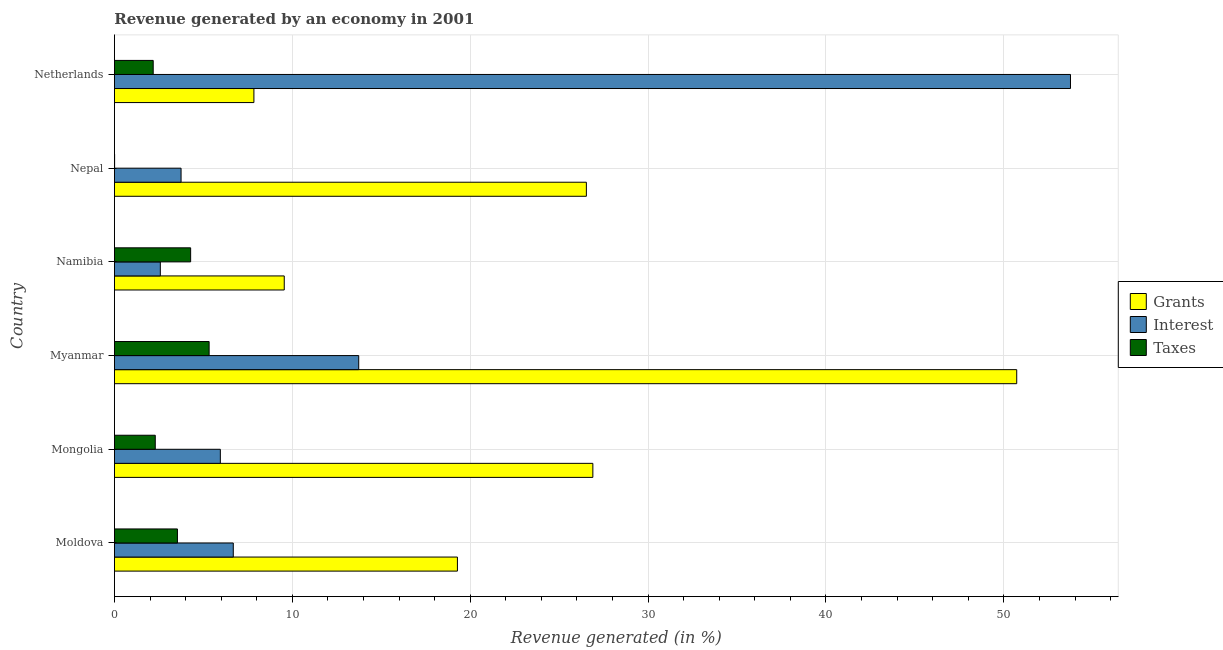How many groups of bars are there?
Your response must be concise. 6. Are the number of bars on each tick of the Y-axis equal?
Your answer should be compact. Yes. How many bars are there on the 6th tick from the top?
Make the answer very short. 3. What is the label of the 4th group of bars from the top?
Offer a terse response. Myanmar. What is the percentage of revenue generated by grants in Netherlands?
Ensure brevity in your answer.  7.84. Across all countries, what is the maximum percentage of revenue generated by interest?
Offer a terse response. 53.74. Across all countries, what is the minimum percentage of revenue generated by interest?
Provide a short and direct response. 2.58. In which country was the percentage of revenue generated by grants maximum?
Keep it short and to the point. Myanmar. What is the total percentage of revenue generated by taxes in the graph?
Your response must be concise. 17.64. What is the difference between the percentage of revenue generated by grants in Moldova and that in Namibia?
Give a very brief answer. 9.73. What is the difference between the percentage of revenue generated by taxes in Netherlands and the percentage of revenue generated by interest in Moldova?
Provide a succinct answer. -4.5. What is the average percentage of revenue generated by taxes per country?
Your answer should be compact. 2.94. What is the difference between the percentage of revenue generated by grants and percentage of revenue generated by taxes in Moldova?
Your answer should be very brief. 15.74. What is the ratio of the percentage of revenue generated by grants in Mongolia to that in Nepal?
Your answer should be very brief. 1.01. Is the percentage of revenue generated by taxes in Mongolia less than that in Namibia?
Make the answer very short. Yes. Is the difference between the percentage of revenue generated by grants in Moldova and Myanmar greater than the difference between the percentage of revenue generated by taxes in Moldova and Myanmar?
Give a very brief answer. No. What is the difference between the highest and the second highest percentage of revenue generated by grants?
Offer a terse response. 23.83. What is the difference between the highest and the lowest percentage of revenue generated by taxes?
Ensure brevity in your answer.  5.31. What does the 2nd bar from the top in Netherlands represents?
Make the answer very short. Interest. What does the 3rd bar from the bottom in Netherlands represents?
Provide a succinct answer. Taxes. Is it the case that in every country, the sum of the percentage of revenue generated by grants and percentage of revenue generated by interest is greater than the percentage of revenue generated by taxes?
Ensure brevity in your answer.  Yes. How many countries are there in the graph?
Keep it short and to the point. 6. Are the values on the major ticks of X-axis written in scientific E-notation?
Provide a succinct answer. No. Does the graph contain any zero values?
Provide a short and direct response. No. Where does the legend appear in the graph?
Provide a succinct answer. Center right. How many legend labels are there?
Ensure brevity in your answer.  3. What is the title of the graph?
Your answer should be very brief. Revenue generated by an economy in 2001. Does "Taxes" appear as one of the legend labels in the graph?
Keep it short and to the point. Yes. What is the label or title of the X-axis?
Your answer should be very brief. Revenue generated (in %). What is the label or title of the Y-axis?
Your answer should be compact. Country. What is the Revenue generated (in %) of Grants in Moldova?
Offer a very short reply. 19.28. What is the Revenue generated (in %) of Interest in Moldova?
Make the answer very short. 6.68. What is the Revenue generated (in %) in Taxes in Moldova?
Provide a short and direct response. 3.54. What is the Revenue generated (in %) of Grants in Mongolia?
Make the answer very short. 26.89. What is the Revenue generated (in %) of Interest in Mongolia?
Make the answer very short. 5.95. What is the Revenue generated (in %) of Taxes in Mongolia?
Give a very brief answer. 2.3. What is the Revenue generated (in %) of Grants in Myanmar?
Provide a short and direct response. 50.72. What is the Revenue generated (in %) in Interest in Myanmar?
Keep it short and to the point. 13.73. What is the Revenue generated (in %) of Taxes in Myanmar?
Provide a short and direct response. 5.32. What is the Revenue generated (in %) of Grants in Namibia?
Give a very brief answer. 9.55. What is the Revenue generated (in %) in Interest in Namibia?
Keep it short and to the point. 2.58. What is the Revenue generated (in %) of Taxes in Namibia?
Offer a terse response. 4.28. What is the Revenue generated (in %) in Grants in Nepal?
Offer a very short reply. 26.53. What is the Revenue generated (in %) in Interest in Nepal?
Provide a succinct answer. 3.75. What is the Revenue generated (in %) of Taxes in Nepal?
Your answer should be very brief. 0.01. What is the Revenue generated (in %) in Grants in Netherlands?
Provide a short and direct response. 7.84. What is the Revenue generated (in %) of Interest in Netherlands?
Keep it short and to the point. 53.74. What is the Revenue generated (in %) of Taxes in Netherlands?
Provide a short and direct response. 2.18. Across all countries, what is the maximum Revenue generated (in %) of Grants?
Keep it short and to the point. 50.72. Across all countries, what is the maximum Revenue generated (in %) of Interest?
Offer a very short reply. 53.74. Across all countries, what is the maximum Revenue generated (in %) in Taxes?
Your answer should be very brief. 5.32. Across all countries, what is the minimum Revenue generated (in %) in Grants?
Your answer should be very brief. 7.84. Across all countries, what is the minimum Revenue generated (in %) in Interest?
Your answer should be compact. 2.58. Across all countries, what is the minimum Revenue generated (in %) of Taxes?
Your response must be concise. 0.01. What is the total Revenue generated (in %) of Grants in the graph?
Offer a terse response. 140.81. What is the total Revenue generated (in %) in Interest in the graph?
Your answer should be compact. 86.44. What is the total Revenue generated (in %) in Taxes in the graph?
Make the answer very short. 17.64. What is the difference between the Revenue generated (in %) in Grants in Moldova and that in Mongolia?
Offer a terse response. -7.61. What is the difference between the Revenue generated (in %) of Interest in Moldova and that in Mongolia?
Provide a succinct answer. 0.73. What is the difference between the Revenue generated (in %) in Taxes in Moldova and that in Mongolia?
Your answer should be very brief. 1.25. What is the difference between the Revenue generated (in %) of Grants in Moldova and that in Myanmar?
Provide a short and direct response. -31.44. What is the difference between the Revenue generated (in %) of Interest in Moldova and that in Myanmar?
Offer a terse response. -7.05. What is the difference between the Revenue generated (in %) of Taxes in Moldova and that in Myanmar?
Your answer should be compact. -1.78. What is the difference between the Revenue generated (in %) of Grants in Moldova and that in Namibia?
Give a very brief answer. 9.73. What is the difference between the Revenue generated (in %) in Interest in Moldova and that in Namibia?
Ensure brevity in your answer.  4.1. What is the difference between the Revenue generated (in %) of Taxes in Moldova and that in Namibia?
Provide a succinct answer. -0.74. What is the difference between the Revenue generated (in %) in Grants in Moldova and that in Nepal?
Provide a short and direct response. -7.25. What is the difference between the Revenue generated (in %) in Interest in Moldova and that in Nepal?
Ensure brevity in your answer.  2.94. What is the difference between the Revenue generated (in %) in Taxes in Moldova and that in Nepal?
Ensure brevity in your answer.  3.53. What is the difference between the Revenue generated (in %) of Grants in Moldova and that in Netherlands?
Make the answer very short. 11.44. What is the difference between the Revenue generated (in %) in Interest in Moldova and that in Netherlands?
Give a very brief answer. -47.06. What is the difference between the Revenue generated (in %) of Taxes in Moldova and that in Netherlands?
Ensure brevity in your answer.  1.36. What is the difference between the Revenue generated (in %) in Grants in Mongolia and that in Myanmar?
Your response must be concise. -23.83. What is the difference between the Revenue generated (in %) in Interest in Mongolia and that in Myanmar?
Make the answer very short. -7.78. What is the difference between the Revenue generated (in %) of Taxes in Mongolia and that in Myanmar?
Your answer should be compact. -3.03. What is the difference between the Revenue generated (in %) in Grants in Mongolia and that in Namibia?
Keep it short and to the point. 17.35. What is the difference between the Revenue generated (in %) of Interest in Mongolia and that in Namibia?
Your answer should be very brief. 3.37. What is the difference between the Revenue generated (in %) in Taxes in Mongolia and that in Namibia?
Offer a terse response. -1.99. What is the difference between the Revenue generated (in %) in Grants in Mongolia and that in Nepal?
Provide a short and direct response. 0.37. What is the difference between the Revenue generated (in %) in Interest in Mongolia and that in Nepal?
Your response must be concise. 2.21. What is the difference between the Revenue generated (in %) in Taxes in Mongolia and that in Nepal?
Your response must be concise. 2.29. What is the difference between the Revenue generated (in %) in Grants in Mongolia and that in Netherlands?
Ensure brevity in your answer.  19.05. What is the difference between the Revenue generated (in %) in Interest in Mongolia and that in Netherlands?
Make the answer very short. -47.79. What is the difference between the Revenue generated (in %) of Taxes in Mongolia and that in Netherlands?
Provide a succinct answer. 0.12. What is the difference between the Revenue generated (in %) in Grants in Myanmar and that in Namibia?
Provide a succinct answer. 41.18. What is the difference between the Revenue generated (in %) in Interest in Myanmar and that in Namibia?
Your response must be concise. 11.15. What is the difference between the Revenue generated (in %) of Taxes in Myanmar and that in Namibia?
Offer a terse response. 1.04. What is the difference between the Revenue generated (in %) of Grants in Myanmar and that in Nepal?
Your answer should be compact. 24.19. What is the difference between the Revenue generated (in %) of Interest in Myanmar and that in Nepal?
Offer a terse response. 9.99. What is the difference between the Revenue generated (in %) of Taxes in Myanmar and that in Nepal?
Give a very brief answer. 5.31. What is the difference between the Revenue generated (in %) in Grants in Myanmar and that in Netherlands?
Provide a succinct answer. 42.88. What is the difference between the Revenue generated (in %) in Interest in Myanmar and that in Netherlands?
Your response must be concise. -40.01. What is the difference between the Revenue generated (in %) of Taxes in Myanmar and that in Netherlands?
Your response must be concise. 3.14. What is the difference between the Revenue generated (in %) in Grants in Namibia and that in Nepal?
Your answer should be compact. -16.98. What is the difference between the Revenue generated (in %) of Interest in Namibia and that in Nepal?
Provide a succinct answer. -1.17. What is the difference between the Revenue generated (in %) of Taxes in Namibia and that in Nepal?
Your answer should be compact. 4.27. What is the difference between the Revenue generated (in %) in Grants in Namibia and that in Netherlands?
Your answer should be compact. 1.71. What is the difference between the Revenue generated (in %) in Interest in Namibia and that in Netherlands?
Give a very brief answer. -51.16. What is the difference between the Revenue generated (in %) of Taxes in Namibia and that in Netherlands?
Provide a succinct answer. 2.1. What is the difference between the Revenue generated (in %) of Grants in Nepal and that in Netherlands?
Give a very brief answer. 18.69. What is the difference between the Revenue generated (in %) of Interest in Nepal and that in Netherlands?
Offer a very short reply. -50. What is the difference between the Revenue generated (in %) in Taxes in Nepal and that in Netherlands?
Keep it short and to the point. -2.17. What is the difference between the Revenue generated (in %) of Grants in Moldova and the Revenue generated (in %) of Interest in Mongolia?
Offer a very short reply. 13.33. What is the difference between the Revenue generated (in %) of Grants in Moldova and the Revenue generated (in %) of Taxes in Mongolia?
Keep it short and to the point. 16.99. What is the difference between the Revenue generated (in %) of Interest in Moldova and the Revenue generated (in %) of Taxes in Mongolia?
Offer a very short reply. 4.39. What is the difference between the Revenue generated (in %) in Grants in Moldova and the Revenue generated (in %) in Interest in Myanmar?
Ensure brevity in your answer.  5.55. What is the difference between the Revenue generated (in %) in Grants in Moldova and the Revenue generated (in %) in Taxes in Myanmar?
Offer a very short reply. 13.96. What is the difference between the Revenue generated (in %) in Interest in Moldova and the Revenue generated (in %) in Taxes in Myanmar?
Your response must be concise. 1.36. What is the difference between the Revenue generated (in %) in Grants in Moldova and the Revenue generated (in %) in Interest in Namibia?
Keep it short and to the point. 16.7. What is the difference between the Revenue generated (in %) in Grants in Moldova and the Revenue generated (in %) in Taxes in Namibia?
Offer a very short reply. 15. What is the difference between the Revenue generated (in %) of Interest in Moldova and the Revenue generated (in %) of Taxes in Namibia?
Make the answer very short. 2.4. What is the difference between the Revenue generated (in %) in Grants in Moldova and the Revenue generated (in %) in Interest in Nepal?
Your answer should be compact. 15.54. What is the difference between the Revenue generated (in %) in Grants in Moldova and the Revenue generated (in %) in Taxes in Nepal?
Offer a very short reply. 19.27. What is the difference between the Revenue generated (in %) of Interest in Moldova and the Revenue generated (in %) of Taxes in Nepal?
Provide a succinct answer. 6.67. What is the difference between the Revenue generated (in %) of Grants in Moldova and the Revenue generated (in %) of Interest in Netherlands?
Ensure brevity in your answer.  -34.46. What is the difference between the Revenue generated (in %) of Grants in Moldova and the Revenue generated (in %) of Taxes in Netherlands?
Your response must be concise. 17.1. What is the difference between the Revenue generated (in %) in Interest in Moldova and the Revenue generated (in %) in Taxes in Netherlands?
Provide a succinct answer. 4.5. What is the difference between the Revenue generated (in %) of Grants in Mongolia and the Revenue generated (in %) of Interest in Myanmar?
Your response must be concise. 13.16. What is the difference between the Revenue generated (in %) of Grants in Mongolia and the Revenue generated (in %) of Taxes in Myanmar?
Offer a very short reply. 21.57. What is the difference between the Revenue generated (in %) in Interest in Mongolia and the Revenue generated (in %) in Taxes in Myanmar?
Make the answer very short. 0.63. What is the difference between the Revenue generated (in %) of Grants in Mongolia and the Revenue generated (in %) of Interest in Namibia?
Give a very brief answer. 24.31. What is the difference between the Revenue generated (in %) of Grants in Mongolia and the Revenue generated (in %) of Taxes in Namibia?
Give a very brief answer. 22.61. What is the difference between the Revenue generated (in %) of Interest in Mongolia and the Revenue generated (in %) of Taxes in Namibia?
Your answer should be very brief. 1.67. What is the difference between the Revenue generated (in %) in Grants in Mongolia and the Revenue generated (in %) in Interest in Nepal?
Offer a terse response. 23.15. What is the difference between the Revenue generated (in %) in Grants in Mongolia and the Revenue generated (in %) in Taxes in Nepal?
Your answer should be very brief. 26.88. What is the difference between the Revenue generated (in %) of Interest in Mongolia and the Revenue generated (in %) of Taxes in Nepal?
Offer a terse response. 5.94. What is the difference between the Revenue generated (in %) of Grants in Mongolia and the Revenue generated (in %) of Interest in Netherlands?
Your response must be concise. -26.85. What is the difference between the Revenue generated (in %) of Grants in Mongolia and the Revenue generated (in %) of Taxes in Netherlands?
Your answer should be compact. 24.71. What is the difference between the Revenue generated (in %) of Interest in Mongolia and the Revenue generated (in %) of Taxes in Netherlands?
Offer a very short reply. 3.77. What is the difference between the Revenue generated (in %) of Grants in Myanmar and the Revenue generated (in %) of Interest in Namibia?
Your answer should be very brief. 48.14. What is the difference between the Revenue generated (in %) in Grants in Myanmar and the Revenue generated (in %) in Taxes in Namibia?
Ensure brevity in your answer.  46.44. What is the difference between the Revenue generated (in %) in Interest in Myanmar and the Revenue generated (in %) in Taxes in Namibia?
Keep it short and to the point. 9.45. What is the difference between the Revenue generated (in %) of Grants in Myanmar and the Revenue generated (in %) of Interest in Nepal?
Provide a short and direct response. 46.98. What is the difference between the Revenue generated (in %) of Grants in Myanmar and the Revenue generated (in %) of Taxes in Nepal?
Keep it short and to the point. 50.71. What is the difference between the Revenue generated (in %) in Interest in Myanmar and the Revenue generated (in %) in Taxes in Nepal?
Your answer should be very brief. 13.72. What is the difference between the Revenue generated (in %) in Grants in Myanmar and the Revenue generated (in %) in Interest in Netherlands?
Ensure brevity in your answer.  -3.02. What is the difference between the Revenue generated (in %) in Grants in Myanmar and the Revenue generated (in %) in Taxes in Netherlands?
Offer a very short reply. 48.54. What is the difference between the Revenue generated (in %) in Interest in Myanmar and the Revenue generated (in %) in Taxes in Netherlands?
Offer a very short reply. 11.55. What is the difference between the Revenue generated (in %) of Grants in Namibia and the Revenue generated (in %) of Interest in Nepal?
Ensure brevity in your answer.  5.8. What is the difference between the Revenue generated (in %) of Grants in Namibia and the Revenue generated (in %) of Taxes in Nepal?
Give a very brief answer. 9.54. What is the difference between the Revenue generated (in %) in Interest in Namibia and the Revenue generated (in %) in Taxes in Nepal?
Your answer should be very brief. 2.57. What is the difference between the Revenue generated (in %) in Grants in Namibia and the Revenue generated (in %) in Interest in Netherlands?
Offer a terse response. -44.2. What is the difference between the Revenue generated (in %) of Grants in Namibia and the Revenue generated (in %) of Taxes in Netherlands?
Your answer should be compact. 7.37. What is the difference between the Revenue generated (in %) of Interest in Namibia and the Revenue generated (in %) of Taxes in Netherlands?
Offer a very short reply. 0.4. What is the difference between the Revenue generated (in %) of Grants in Nepal and the Revenue generated (in %) of Interest in Netherlands?
Ensure brevity in your answer.  -27.21. What is the difference between the Revenue generated (in %) of Grants in Nepal and the Revenue generated (in %) of Taxes in Netherlands?
Ensure brevity in your answer.  24.35. What is the difference between the Revenue generated (in %) in Interest in Nepal and the Revenue generated (in %) in Taxes in Netherlands?
Your response must be concise. 1.57. What is the average Revenue generated (in %) in Grants per country?
Provide a short and direct response. 23.47. What is the average Revenue generated (in %) in Interest per country?
Your answer should be compact. 14.41. What is the average Revenue generated (in %) of Taxes per country?
Your answer should be very brief. 2.94. What is the difference between the Revenue generated (in %) in Grants and Revenue generated (in %) in Interest in Moldova?
Provide a succinct answer. 12.6. What is the difference between the Revenue generated (in %) in Grants and Revenue generated (in %) in Taxes in Moldova?
Your answer should be very brief. 15.74. What is the difference between the Revenue generated (in %) of Interest and Revenue generated (in %) of Taxes in Moldova?
Keep it short and to the point. 3.14. What is the difference between the Revenue generated (in %) of Grants and Revenue generated (in %) of Interest in Mongolia?
Your answer should be compact. 20.94. What is the difference between the Revenue generated (in %) of Grants and Revenue generated (in %) of Taxes in Mongolia?
Offer a terse response. 24.6. What is the difference between the Revenue generated (in %) of Interest and Revenue generated (in %) of Taxes in Mongolia?
Keep it short and to the point. 3.66. What is the difference between the Revenue generated (in %) of Grants and Revenue generated (in %) of Interest in Myanmar?
Make the answer very short. 36.99. What is the difference between the Revenue generated (in %) of Grants and Revenue generated (in %) of Taxes in Myanmar?
Your response must be concise. 45.4. What is the difference between the Revenue generated (in %) of Interest and Revenue generated (in %) of Taxes in Myanmar?
Offer a very short reply. 8.41. What is the difference between the Revenue generated (in %) of Grants and Revenue generated (in %) of Interest in Namibia?
Keep it short and to the point. 6.97. What is the difference between the Revenue generated (in %) in Grants and Revenue generated (in %) in Taxes in Namibia?
Offer a terse response. 5.26. What is the difference between the Revenue generated (in %) in Interest and Revenue generated (in %) in Taxes in Namibia?
Your response must be concise. -1.7. What is the difference between the Revenue generated (in %) in Grants and Revenue generated (in %) in Interest in Nepal?
Provide a short and direct response. 22.78. What is the difference between the Revenue generated (in %) of Grants and Revenue generated (in %) of Taxes in Nepal?
Keep it short and to the point. 26.52. What is the difference between the Revenue generated (in %) in Interest and Revenue generated (in %) in Taxes in Nepal?
Your answer should be very brief. 3.74. What is the difference between the Revenue generated (in %) in Grants and Revenue generated (in %) in Interest in Netherlands?
Offer a very short reply. -45.9. What is the difference between the Revenue generated (in %) of Grants and Revenue generated (in %) of Taxes in Netherlands?
Offer a very short reply. 5.66. What is the difference between the Revenue generated (in %) in Interest and Revenue generated (in %) in Taxes in Netherlands?
Your answer should be very brief. 51.56. What is the ratio of the Revenue generated (in %) of Grants in Moldova to that in Mongolia?
Ensure brevity in your answer.  0.72. What is the ratio of the Revenue generated (in %) of Interest in Moldova to that in Mongolia?
Offer a terse response. 1.12. What is the ratio of the Revenue generated (in %) in Taxes in Moldova to that in Mongolia?
Your answer should be compact. 1.54. What is the ratio of the Revenue generated (in %) of Grants in Moldova to that in Myanmar?
Your response must be concise. 0.38. What is the ratio of the Revenue generated (in %) of Interest in Moldova to that in Myanmar?
Offer a very short reply. 0.49. What is the ratio of the Revenue generated (in %) of Taxes in Moldova to that in Myanmar?
Provide a short and direct response. 0.67. What is the ratio of the Revenue generated (in %) of Grants in Moldova to that in Namibia?
Keep it short and to the point. 2.02. What is the ratio of the Revenue generated (in %) of Interest in Moldova to that in Namibia?
Keep it short and to the point. 2.59. What is the ratio of the Revenue generated (in %) in Taxes in Moldova to that in Namibia?
Give a very brief answer. 0.83. What is the ratio of the Revenue generated (in %) of Grants in Moldova to that in Nepal?
Offer a very short reply. 0.73. What is the ratio of the Revenue generated (in %) of Interest in Moldova to that in Nepal?
Give a very brief answer. 1.78. What is the ratio of the Revenue generated (in %) in Taxes in Moldova to that in Nepal?
Ensure brevity in your answer.  353.88. What is the ratio of the Revenue generated (in %) of Grants in Moldova to that in Netherlands?
Offer a very short reply. 2.46. What is the ratio of the Revenue generated (in %) of Interest in Moldova to that in Netherlands?
Provide a succinct answer. 0.12. What is the ratio of the Revenue generated (in %) of Taxes in Moldova to that in Netherlands?
Your answer should be compact. 1.62. What is the ratio of the Revenue generated (in %) of Grants in Mongolia to that in Myanmar?
Give a very brief answer. 0.53. What is the ratio of the Revenue generated (in %) in Interest in Mongolia to that in Myanmar?
Your answer should be compact. 0.43. What is the ratio of the Revenue generated (in %) in Taxes in Mongolia to that in Myanmar?
Ensure brevity in your answer.  0.43. What is the ratio of the Revenue generated (in %) of Grants in Mongolia to that in Namibia?
Ensure brevity in your answer.  2.82. What is the ratio of the Revenue generated (in %) in Interest in Mongolia to that in Namibia?
Keep it short and to the point. 2.31. What is the ratio of the Revenue generated (in %) in Taxes in Mongolia to that in Namibia?
Your answer should be compact. 0.54. What is the ratio of the Revenue generated (in %) of Grants in Mongolia to that in Nepal?
Provide a short and direct response. 1.01. What is the ratio of the Revenue generated (in %) in Interest in Mongolia to that in Nepal?
Your answer should be compact. 1.59. What is the ratio of the Revenue generated (in %) of Taxes in Mongolia to that in Nepal?
Keep it short and to the point. 229.41. What is the ratio of the Revenue generated (in %) in Grants in Mongolia to that in Netherlands?
Make the answer very short. 3.43. What is the ratio of the Revenue generated (in %) of Interest in Mongolia to that in Netherlands?
Give a very brief answer. 0.11. What is the ratio of the Revenue generated (in %) in Taxes in Mongolia to that in Netherlands?
Make the answer very short. 1.05. What is the ratio of the Revenue generated (in %) in Grants in Myanmar to that in Namibia?
Provide a succinct answer. 5.31. What is the ratio of the Revenue generated (in %) of Interest in Myanmar to that in Namibia?
Offer a very short reply. 5.32. What is the ratio of the Revenue generated (in %) in Taxes in Myanmar to that in Namibia?
Provide a short and direct response. 1.24. What is the ratio of the Revenue generated (in %) of Grants in Myanmar to that in Nepal?
Your answer should be very brief. 1.91. What is the ratio of the Revenue generated (in %) in Interest in Myanmar to that in Nepal?
Your response must be concise. 3.67. What is the ratio of the Revenue generated (in %) of Taxes in Myanmar to that in Nepal?
Your answer should be compact. 531.92. What is the ratio of the Revenue generated (in %) of Grants in Myanmar to that in Netherlands?
Offer a terse response. 6.47. What is the ratio of the Revenue generated (in %) of Interest in Myanmar to that in Netherlands?
Offer a terse response. 0.26. What is the ratio of the Revenue generated (in %) of Taxes in Myanmar to that in Netherlands?
Your answer should be very brief. 2.44. What is the ratio of the Revenue generated (in %) in Grants in Namibia to that in Nepal?
Provide a short and direct response. 0.36. What is the ratio of the Revenue generated (in %) of Interest in Namibia to that in Nepal?
Keep it short and to the point. 0.69. What is the ratio of the Revenue generated (in %) of Taxes in Namibia to that in Nepal?
Provide a short and direct response. 428.09. What is the ratio of the Revenue generated (in %) in Grants in Namibia to that in Netherlands?
Your answer should be very brief. 1.22. What is the ratio of the Revenue generated (in %) of Interest in Namibia to that in Netherlands?
Provide a short and direct response. 0.05. What is the ratio of the Revenue generated (in %) in Taxes in Namibia to that in Netherlands?
Your response must be concise. 1.97. What is the ratio of the Revenue generated (in %) in Grants in Nepal to that in Netherlands?
Your answer should be very brief. 3.38. What is the ratio of the Revenue generated (in %) in Interest in Nepal to that in Netherlands?
Offer a terse response. 0.07. What is the ratio of the Revenue generated (in %) of Taxes in Nepal to that in Netherlands?
Give a very brief answer. 0. What is the difference between the highest and the second highest Revenue generated (in %) of Grants?
Provide a short and direct response. 23.83. What is the difference between the highest and the second highest Revenue generated (in %) of Interest?
Your answer should be very brief. 40.01. What is the difference between the highest and the second highest Revenue generated (in %) of Taxes?
Offer a terse response. 1.04. What is the difference between the highest and the lowest Revenue generated (in %) in Grants?
Your answer should be compact. 42.88. What is the difference between the highest and the lowest Revenue generated (in %) of Interest?
Make the answer very short. 51.16. What is the difference between the highest and the lowest Revenue generated (in %) in Taxes?
Provide a short and direct response. 5.31. 